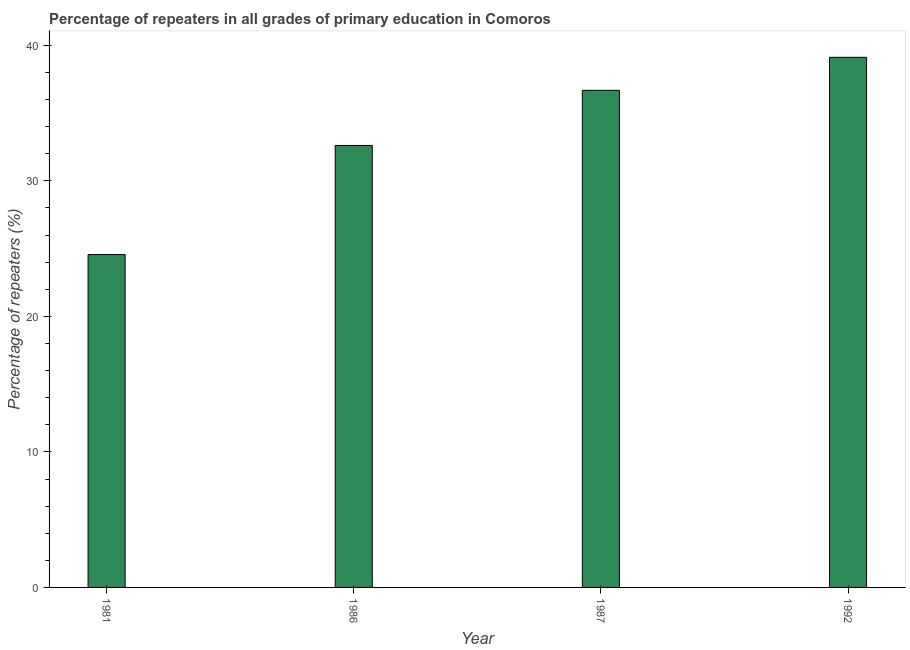Does the graph contain any zero values?
Your response must be concise. No. What is the title of the graph?
Give a very brief answer. Percentage of repeaters in all grades of primary education in Comoros. What is the label or title of the X-axis?
Provide a succinct answer. Year. What is the label or title of the Y-axis?
Ensure brevity in your answer.  Percentage of repeaters (%). What is the percentage of repeaters in primary education in 1981?
Provide a succinct answer. 24.56. Across all years, what is the maximum percentage of repeaters in primary education?
Make the answer very short. 39.12. Across all years, what is the minimum percentage of repeaters in primary education?
Make the answer very short. 24.56. What is the sum of the percentage of repeaters in primary education?
Your response must be concise. 132.98. What is the difference between the percentage of repeaters in primary education in 1987 and 1992?
Offer a terse response. -2.43. What is the average percentage of repeaters in primary education per year?
Provide a succinct answer. 33.24. What is the median percentage of repeaters in primary education?
Offer a terse response. 34.65. Do a majority of the years between 1986 and 1992 (inclusive) have percentage of repeaters in primary education greater than 20 %?
Your answer should be very brief. Yes. What is the ratio of the percentage of repeaters in primary education in 1981 to that in 1992?
Give a very brief answer. 0.63. Is the percentage of repeaters in primary education in 1981 less than that in 1992?
Your answer should be compact. Yes. Is the difference between the percentage of repeaters in primary education in 1981 and 1986 greater than the difference between any two years?
Your answer should be compact. No. What is the difference between the highest and the second highest percentage of repeaters in primary education?
Your response must be concise. 2.43. What is the difference between the highest and the lowest percentage of repeaters in primary education?
Keep it short and to the point. 14.56. In how many years, is the percentage of repeaters in primary education greater than the average percentage of repeaters in primary education taken over all years?
Ensure brevity in your answer.  2. Are all the bars in the graph horizontal?
Offer a terse response. No. How many years are there in the graph?
Give a very brief answer. 4. What is the difference between two consecutive major ticks on the Y-axis?
Provide a succinct answer. 10. What is the Percentage of repeaters (%) in 1981?
Your answer should be compact. 24.56. What is the Percentage of repeaters (%) in 1986?
Keep it short and to the point. 32.61. What is the Percentage of repeaters (%) in 1987?
Make the answer very short. 36.68. What is the Percentage of repeaters (%) of 1992?
Your response must be concise. 39.12. What is the difference between the Percentage of repeaters (%) in 1981 and 1986?
Provide a succinct answer. -8.05. What is the difference between the Percentage of repeaters (%) in 1981 and 1987?
Ensure brevity in your answer.  -12.12. What is the difference between the Percentage of repeaters (%) in 1981 and 1992?
Your answer should be compact. -14.56. What is the difference between the Percentage of repeaters (%) in 1986 and 1987?
Your answer should be very brief. -4.07. What is the difference between the Percentage of repeaters (%) in 1986 and 1992?
Your answer should be very brief. -6.5. What is the difference between the Percentage of repeaters (%) in 1987 and 1992?
Your answer should be very brief. -2.43. What is the ratio of the Percentage of repeaters (%) in 1981 to that in 1986?
Offer a very short reply. 0.75. What is the ratio of the Percentage of repeaters (%) in 1981 to that in 1987?
Keep it short and to the point. 0.67. What is the ratio of the Percentage of repeaters (%) in 1981 to that in 1992?
Ensure brevity in your answer.  0.63. What is the ratio of the Percentage of repeaters (%) in 1986 to that in 1987?
Make the answer very short. 0.89. What is the ratio of the Percentage of repeaters (%) in 1986 to that in 1992?
Give a very brief answer. 0.83. What is the ratio of the Percentage of repeaters (%) in 1987 to that in 1992?
Ensure brevity in your answer.  0.94. 